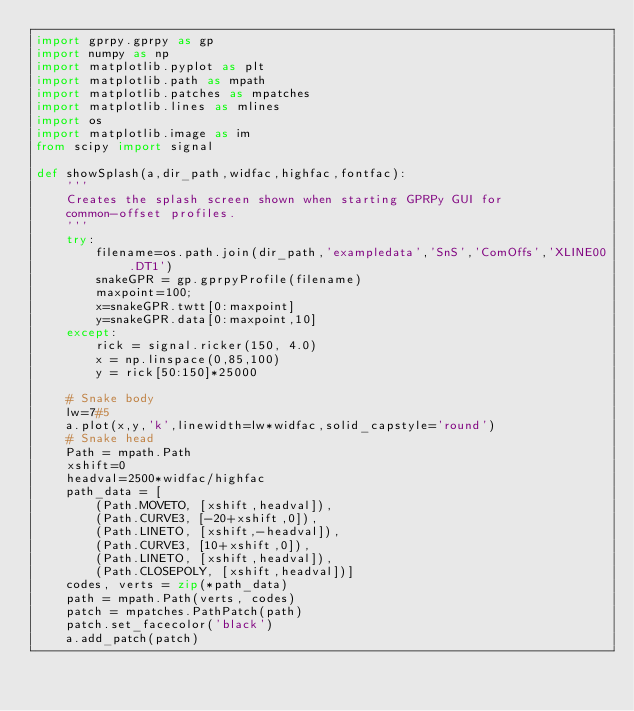<code> <loc_0><loc_0><loc_500><loc_500><_Python_>import gprpy.gprpy as gp
import numpy as np
import matplotlib.pyplot as plt
import matplotlib.path as mpath
import matplotlib.patches as mpatches
import matplotlib.lines as mlines
import os
import matplotlib.image as im
from scipy import signal

def showSplash(a,dir_path,widfac,highfac,fontfac):
    '''
    Creates the splash screen shown when starting GPRPy GUI for 
    common-offset profiles.
    '''
    try:
        filename=os.path.join(dir_path,'exampledata','SnS','ComOffs','XLINE00.DT1')
        snakeGPR = gp.gprpyProfile(filename)
        maxpoint=100;
        x=snakeGPR.twtt[0:maxpoint]
        y=snakeGPR.data[0:maxpoint,10]
    except:
        rick = signal.ricker(150, 4.0)
        x = np.linspace(0,85,100)
        y = rick[50:150]*25000
        
    # Snake body
    lw=7#5
    a.plot(x,y,'k',linewidth=lw*widfac,solid_capstyle='round')
    # Snake head
    Path = mpath.Path
    xshift=0
    headval=2500*widfac/highfac
    path_data = [
        (Path.MOVETO, [xshift,headval]),
        (Path.CURVE3, [-20+xshift,0]),
        (Path.LINETO, [xshift,-headval]),
        (Path.CURVE3, [10+xshift,0]),
        (Path.LINETO, [xshift,headval]),
        (Path.CLOSEPOLY, [xshift,headval])]
    codes, verts = zip(*path_data)
    path = mpath.Path(verts, codes)
    patch = mpatches.PathPatch(path)
    patch.set_facecolor('black')
    a.add_patch(patch)</code> 